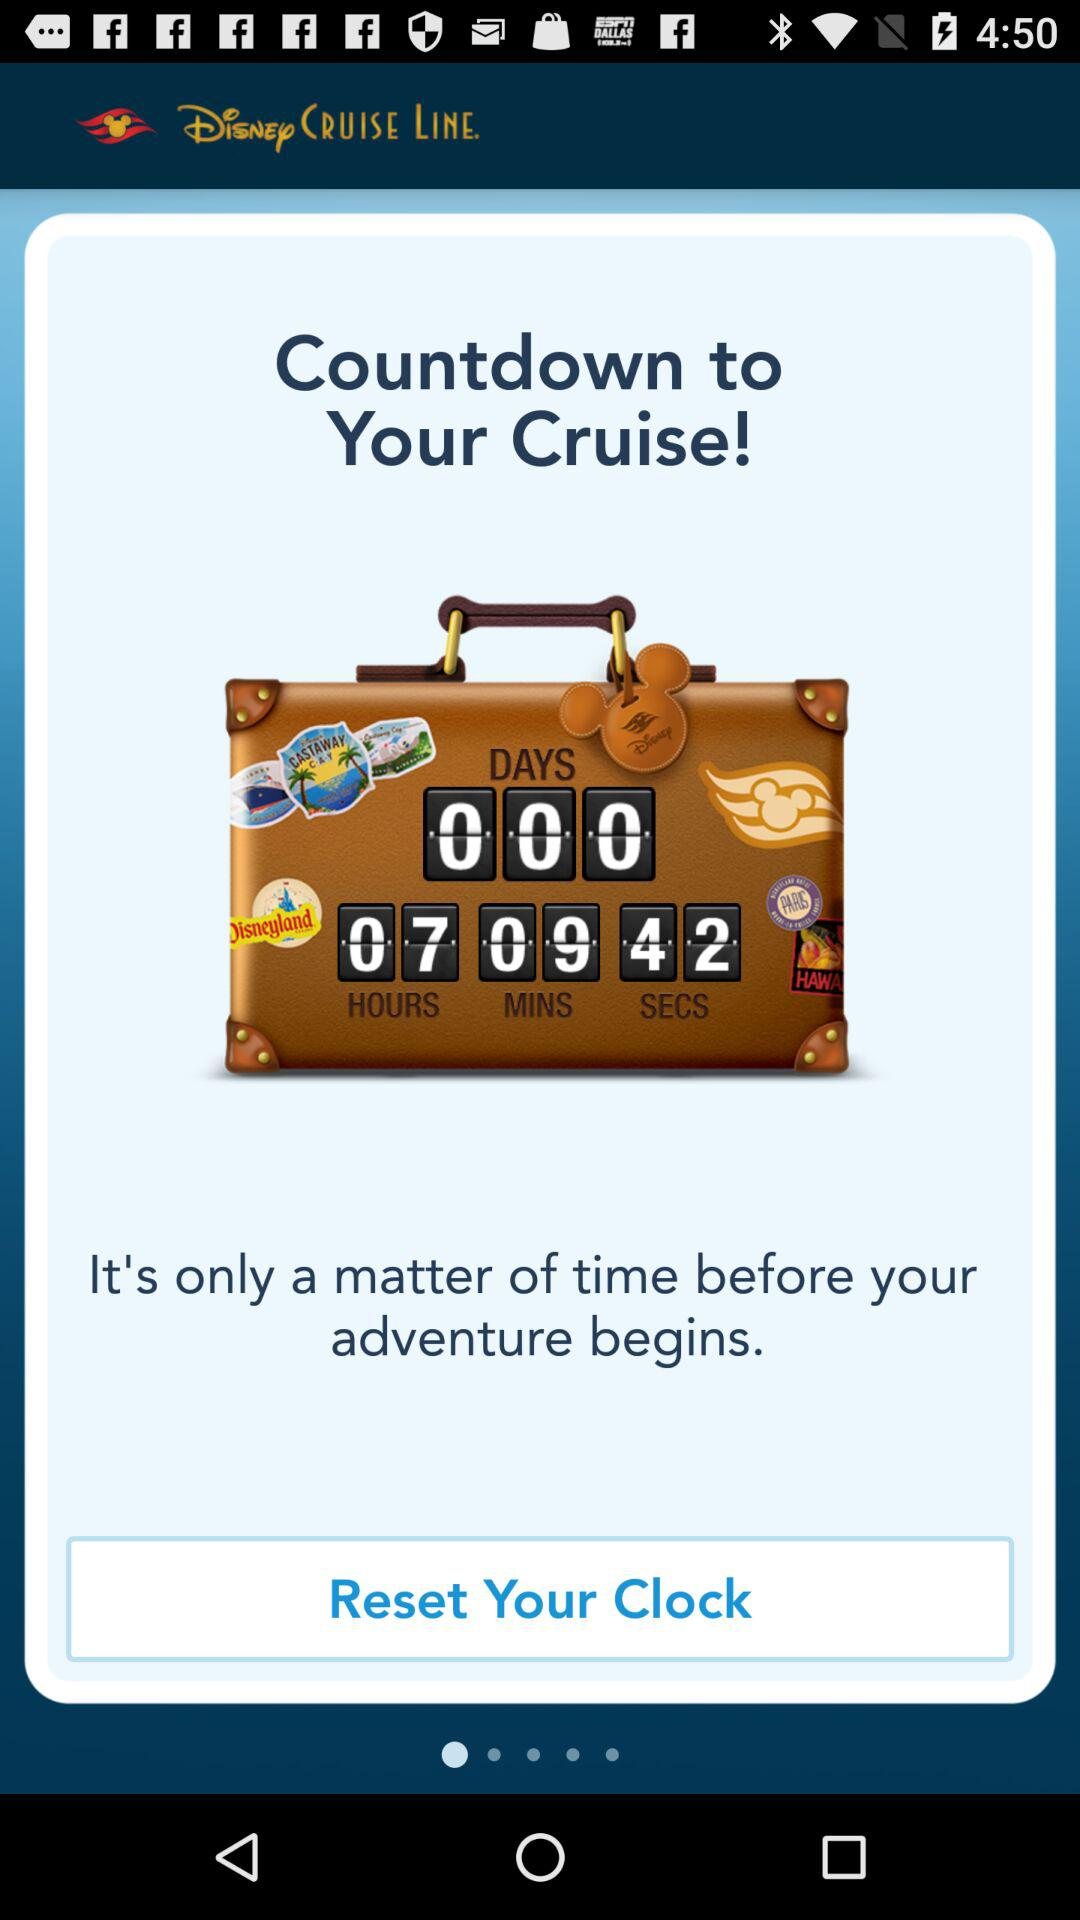How many seconds are left for the countdown to your cruise? There are 42 seconds left. 